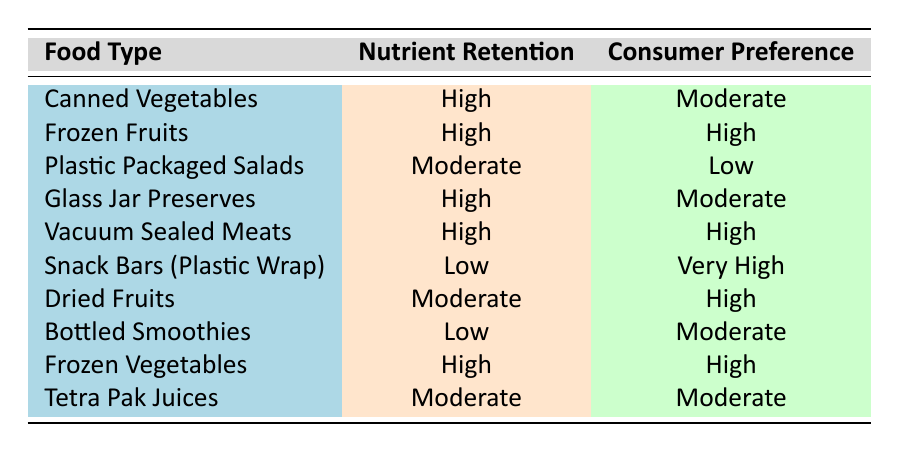What's the consumer preference for Frozen Fruits? The table directly lists Frozen Fruits under the Food Type column, with the corresponding Consumer Preference being "High."
Answer: High Which food type has the lowest consumer preference? By examining the Consumer Preference column, Plastic Packaged Salads shows the lowest preference level marked as "Low."
Answer: Plastic Packaged Salads How many food types have high nutrient retention and high consumer preference? Looking at the Nutrient Retention and Consumer Preference columns, Frozen Fruits and Vacuum Sealed Meats are the two food types that fit both criteria. Thus, there are 2 food types.
Answer: 2 Is it true that all food types with low nutrient retention have high consumer preference? Reviewing the table, Snack Bars (Plastic Wrap) has a Low retention but a Very High preference, while Bottled Smoothies have Low retention and Moderate preference. This means not all low retention food types have high preference.
Answer: No What is the average consumer preference level for food types with moderate nutrient retention? The food types with moderate nutrient retention are Plastic Packaged Salads, Dried Fruits, and Tetra Pak Juices. Their consumer preferences are Low, High, and Moderate respectively. Converting those to a numerical scale (Lowest = 1 for Low, Moderate = 2, High = 3) gives us 1, 3, and 2. The average is (1 + 3 + 2) / 3 = 2. Therefore, the average preference is Moderate.
Answer: Moderate 